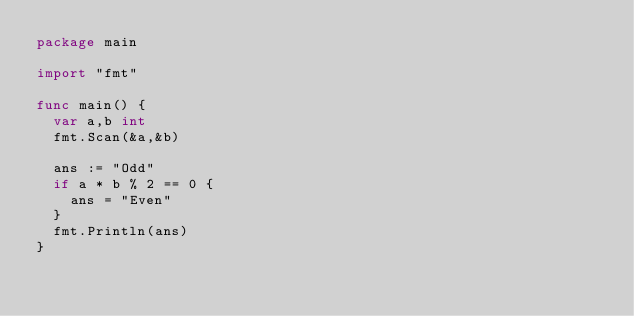Convert code to text. <code><loc_0><loc_0><loc_500><loc_500><_Go_>package main

import "fmt"

func main() {
  var a,b int
  fmt.Scan(&a,&b)

  ans := "Odd"
  if a * b % 2 == 0 {
    ans = "Even"
  }
  fmt.Println(ans)
}</code> 